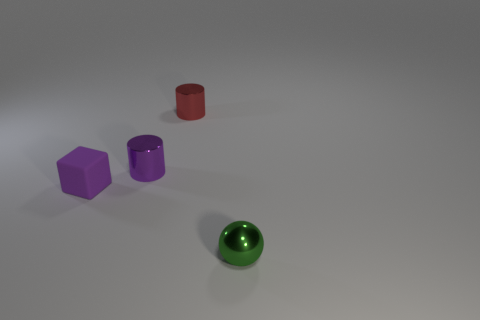Add 1 purple cylinders. How many objects exist? 5 Subtract all balls. How many objects are left? 3 Subtract all tiny red shiny objects. Subtract all purple rubber blocks. How many objects are left? 2 Add 3 small shiny balls. How many small shiny balls are left? 4 Add 3 large purple spheres. How many large purple spheres exist? 3 Subtract 0 red blocks. How many objects are left? 4 